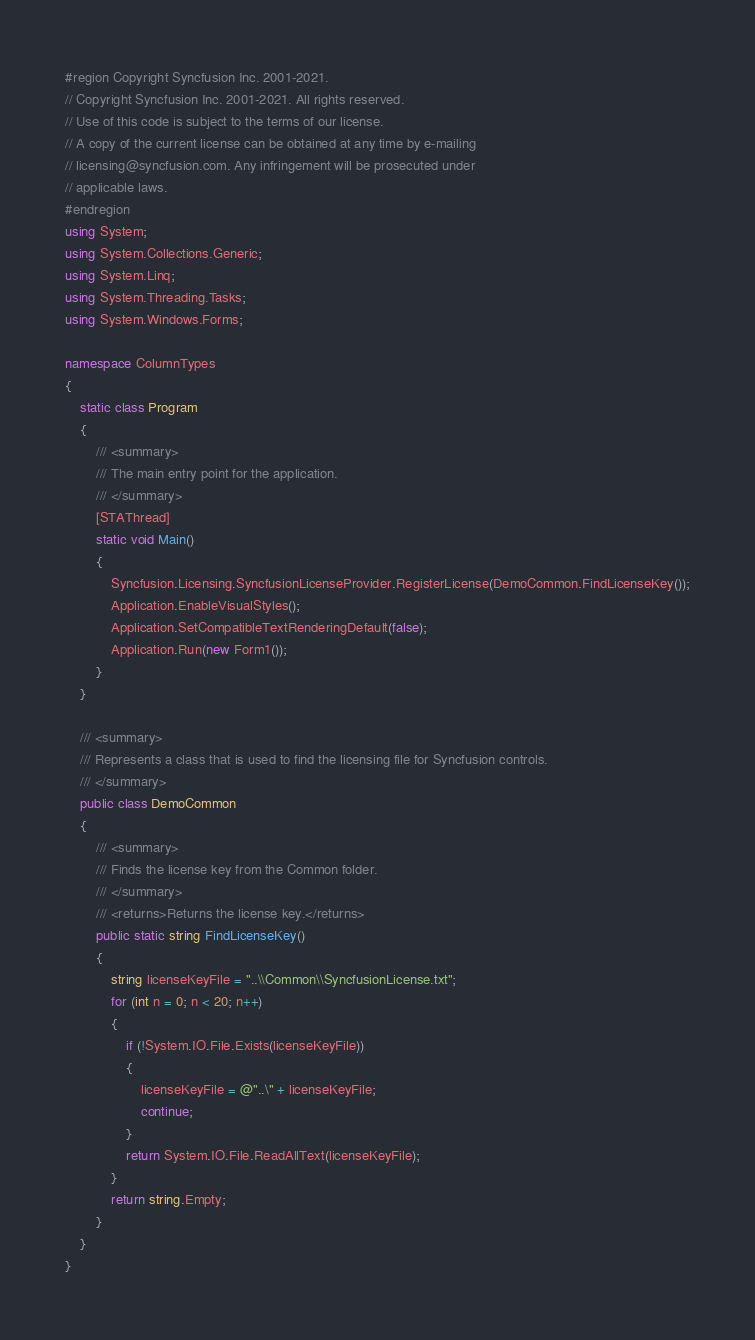<code> <loc_0><loc_0><loc_500><loc_500><_C#_>#region Copyright Syncfusion Inc. 2001-2021.
// Copyright Syncfusion Inc. 2001-2021. All rights reserved.
// Use of this code is subject to the terms of our license.
// A copy of the current license can be obtained at any time by e-mailing
// licensing@syncfusion.com. Any infringement will be prosecuted under
// applicable laws. 
#endregion
using System;
using System.Collections.Generic;
using System.Linq;
using System.Threading.Tasks;
using System.Windows.Forms;

namespace ColumnTypes
{
    static class Program
    {
        /// <summary>
        /// The main entry point for the application.
        /// </summary>
        [STAThread]
        static void Main()
        {
			Syncfusion.Licensing.SyncfusionLicenseProvider.RegisterLicense(DemoCommon.FindLicenseKey());
            Application.EnableVisualStyles();
            Application.SetCompatibleTextRenderingDefault(false);
            Application.Run(new Form1());
        }
    }
	
	/// <summary>
    /// Represents a class that is used to find the licensing file for Syncfusion controls.
    /// </summary>
    public class DemoCommon
    {
        /// <summary>
        /// Finds the license key from the Common folder.
        /// </summary>
        /// <returns>Returns the license key.</returns>
        public static string FindLicenseKey()
        {
            string licenseKeyFile = "..\\Common\\SyncfusionLicense.txt";
            for (int n = 0; n < 20; n++)
            {
                if (!System.IO.File.Exists(licenseKeyFile))
                {
                    licenseKeyFile = @"..\" + licenseKeyFile;
                    continue;
                }
                return System.IO.File.ReadAllText(licenseKeyFile);
            }
            return string.Empty;
        }
    }
}
</code> 